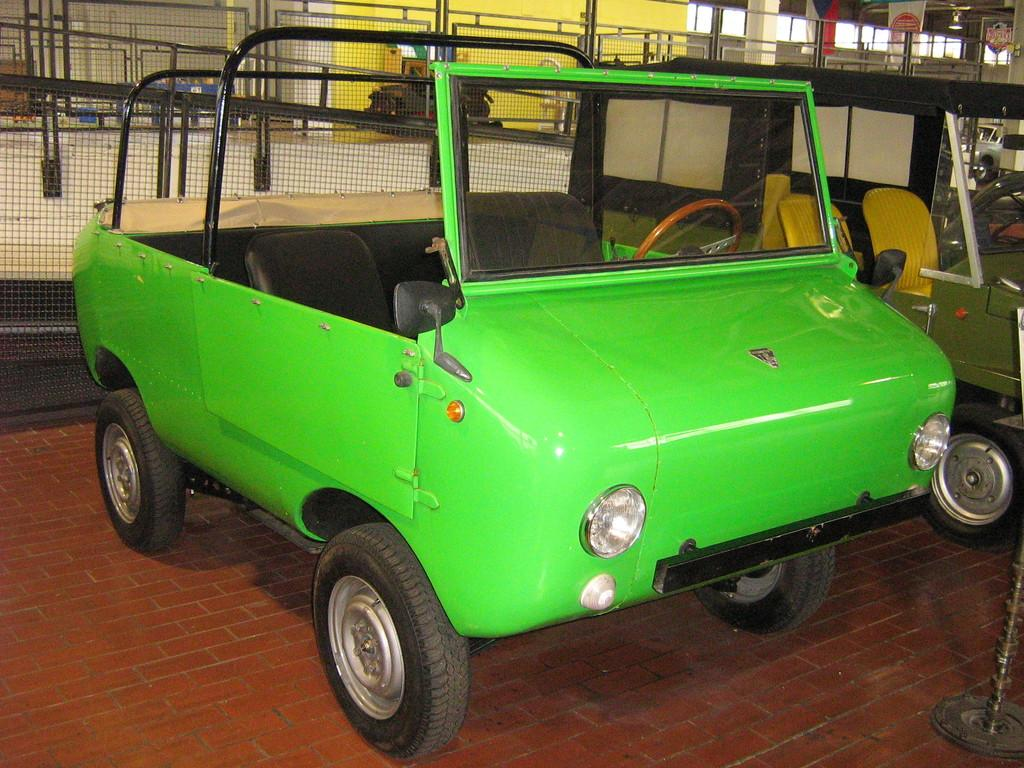What objects are on the floor in the image? There are two vehicles on the floor. What can be seen in the background of the image? There is a fence, a railing, pillars, banners, and a wall in the background. How many vehicles are on the floor? There are two vehicles on the floor. What type of yarn is being used to adjust the height of the vehicles in the image? There is no yarn present in the image, nor is there any adjustment being made to the height of the vehicles. 